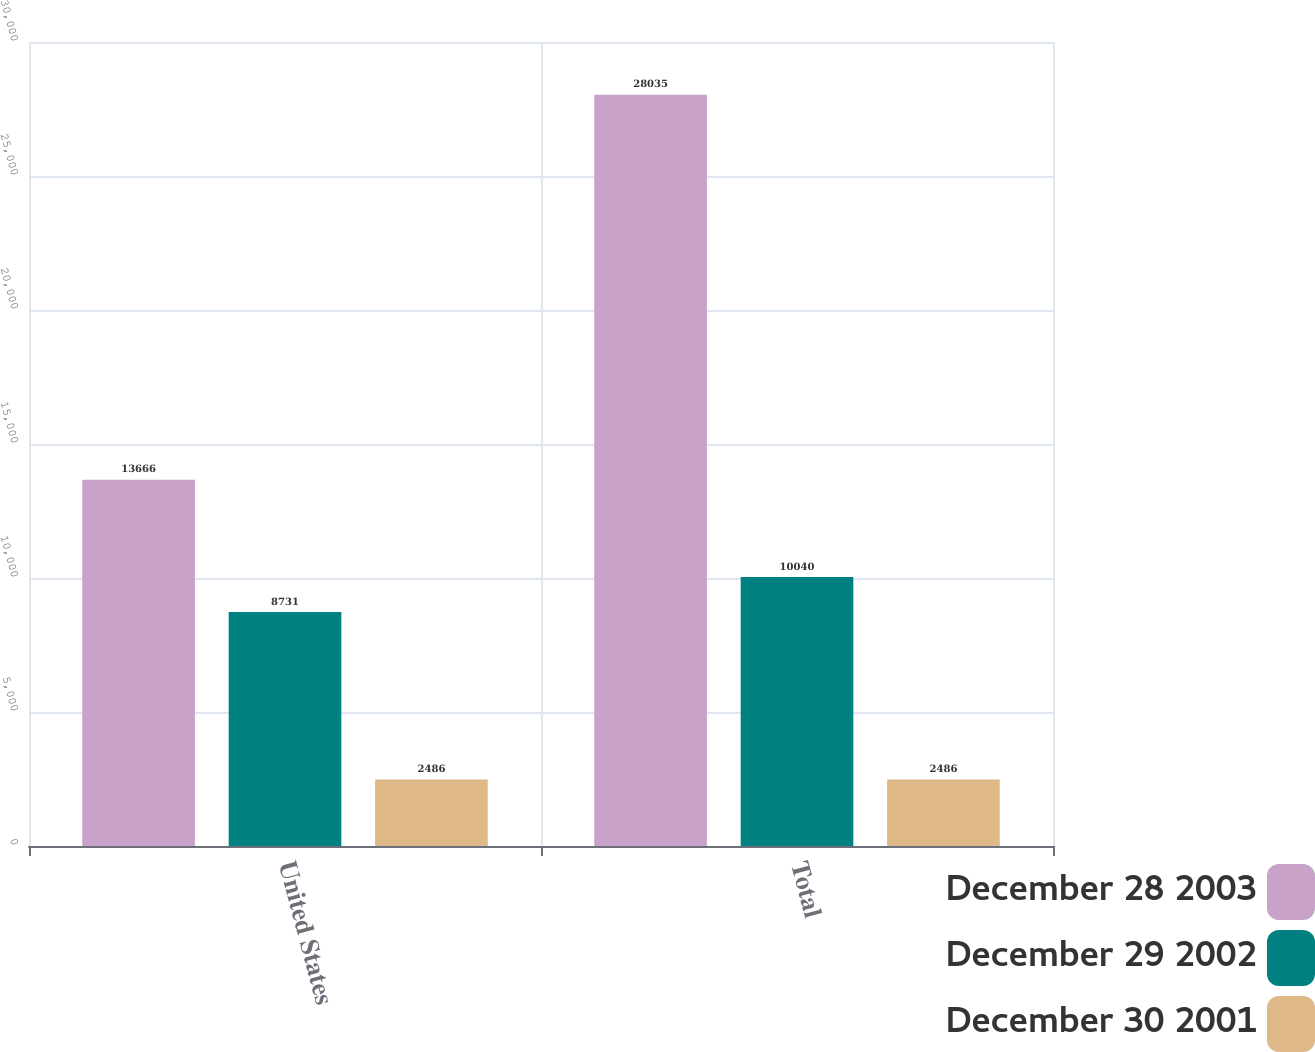Convert chart. <chart><loc_0><loc_0><loc_500><loc_500><stacked_bar_chart><ecel><fcel>United States<fcel>Total<nl><fcel>December 28 2003<fcel>13666<fcel>28035<nl><fcel>December 29 2002<fcel>8731<fcel>10040<nl><fcel>December 30 2001<fcel>2486<fcel>2486<nl></chart> 